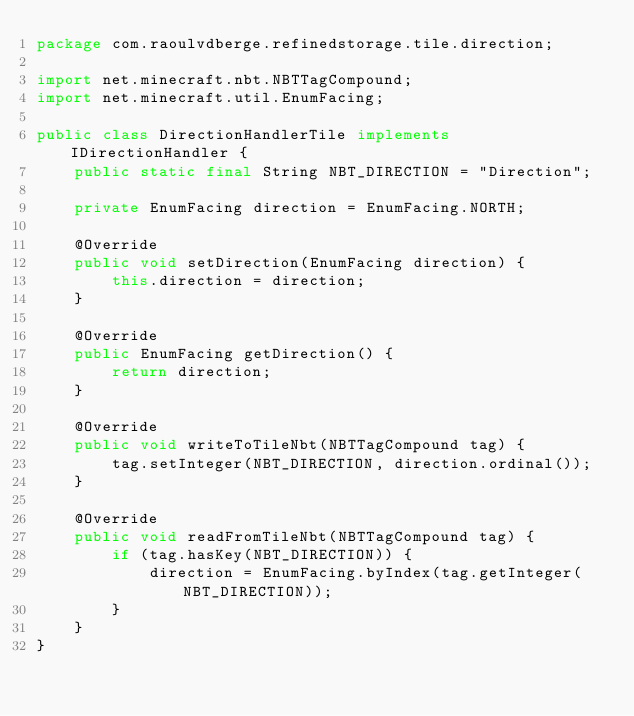<code> <loc_0><loc_0><loc_500><loc_500><_Java_>package com.raoulvdberge.refinedstorage.tile.direction;

import net.minecraft.nbt.NBTTagCompound;
import net.minecraft.util.EnumFacing;

public class DirectionHandlerTile implements IDirectionHandler {
    public static final String NBT_DIRECTION = "Direction";

    private EnumFacing direction = EnumFacing.NORTH;

    @Override
    public void setDirection(EnumFacing direction) {
        this.direction = direction;
    }

    @Override
    public EnumFacing getDirection() {
        return direction;
    }

    @Override
    public void writeToTileNbt(NBTTagCompound tag) {
        tag.setInteger(NBT_DIRECTION, direction.ordinal());
    }

    @Override
    public void readFromTileNbt(NBTTagCompound tag) {
        if (tag.hasKey(NBT_DIRECTION)) {
            direction = EnumFacing.byIndex(tag.getInteger(NBT_DIRECTION));
        }
    }
}
</code> 